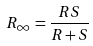Convert formula to latex. <formula><loc_0><loc_0><loc_500><loc_500>R _ { \infty } = \frac { R S } { R + S }</formula> 